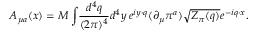<formula> <loc_0><loc_0><loc_500><loc_500>A _ { \mu a } ( x ) = M \int \, { \frac { d ^ { 4 } q } { ( 2 \pi ) ^ { 4 } } } d ^ { 4 } y \, e ^ { i y \cdot q } ( \partial _ { \mu } \pi ^ { a } ) \sqrt { Z _ { \pi } ( q ) } e ^ { - i q \cdot x } .</formula> 